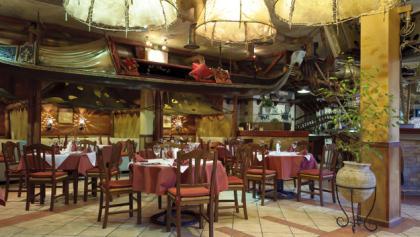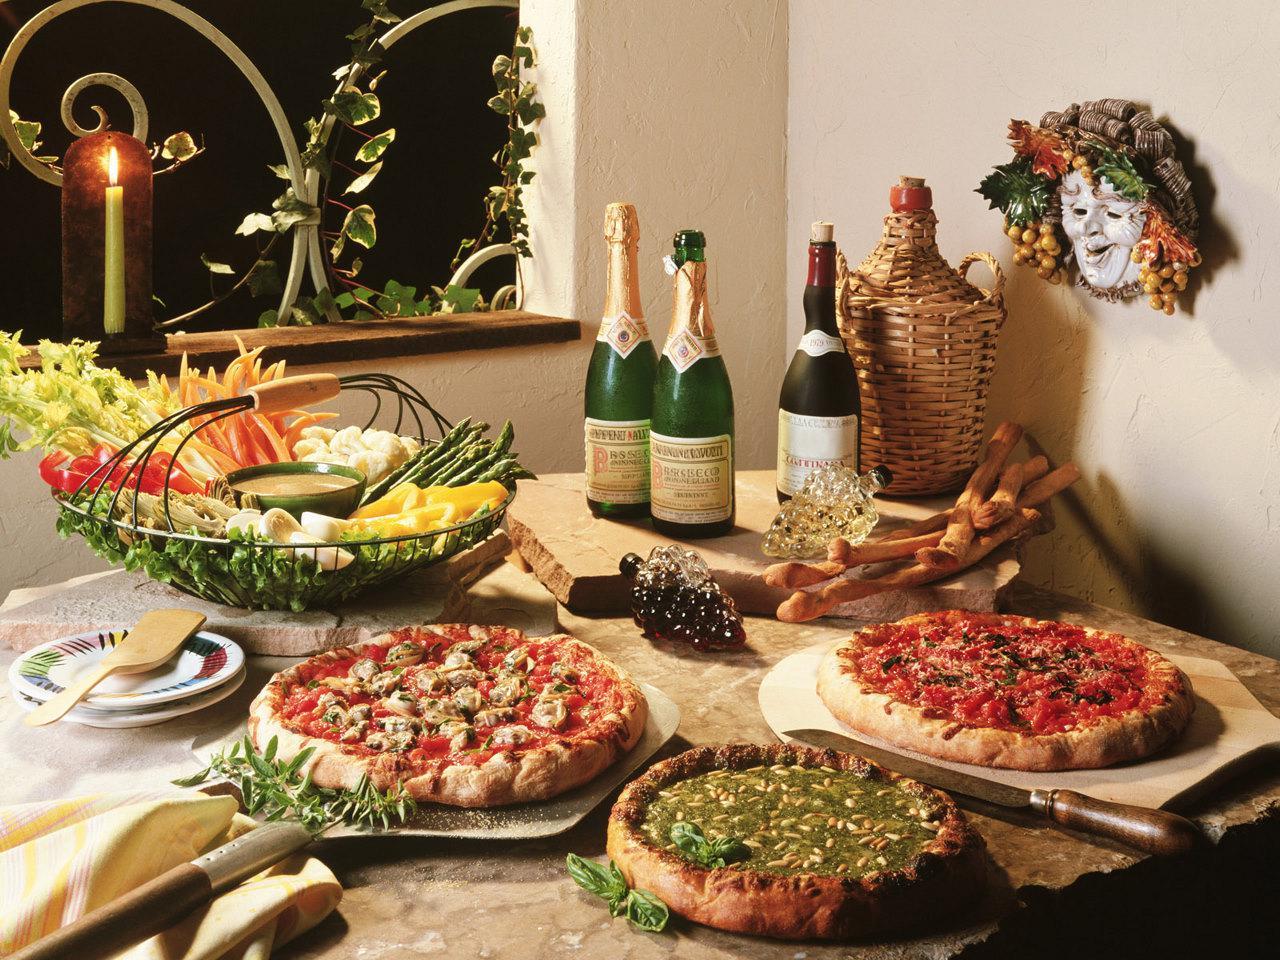The first image is the image on the left, the second image is the image on the right. For the images displayed, is the sentence "Hands are poised over a plate of food on a brown table holding multiple white plates in the right image." factually correct? Answer yes or no. No. 